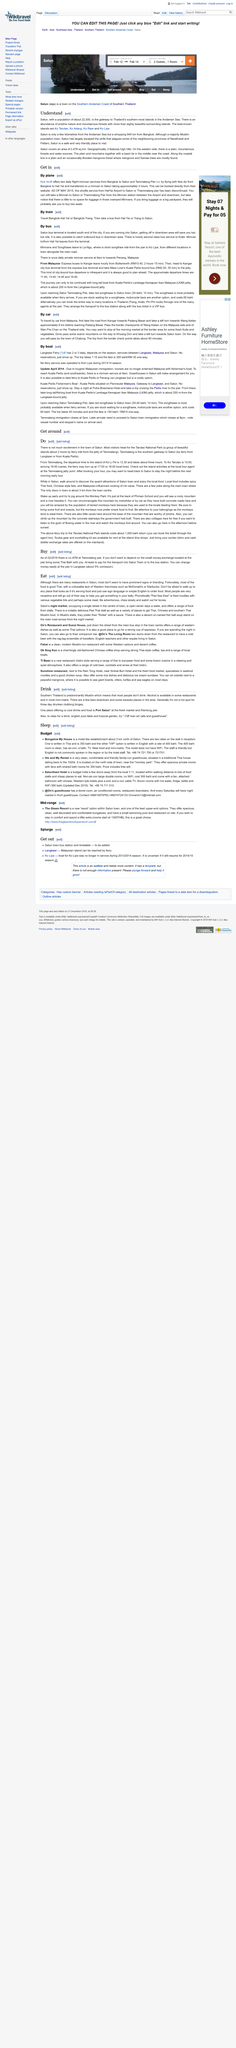Identify some key points in this picture. The religion of the most common people here is Islam. The population of Satun, as stated in the article "Understand," is 22,000. The number of islands surrounding Satun is greater than 80. 